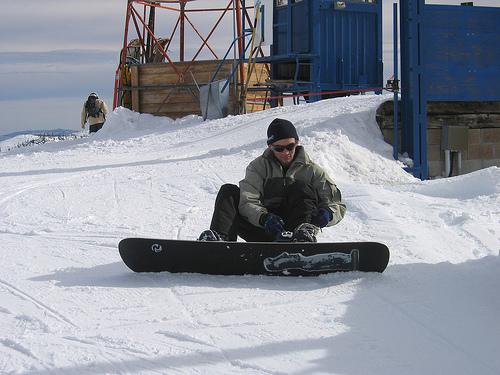Question: what is the man doing?
Choices:
A. Sitting.
B. Eating.
C. Dancing.
D. Walking.
Answer with the letter. Answer: A Question: who is sitting?
Choices:
A. A man.
B. A woman.
C. A dog.
D. A cat.
Answer with the letter. Answer: A Question: why is the man sitting?
Choices:
A. Eating his dinner.
B. Tying his shoe.
C. Tired of standing.
D. Fixing his snowboard.
Answer with the letter. Answer: D Question: when was the photo taken?
Choices:
A. Night time.
B. Winter.
C. Summer.
D. Day time.
Answer with the letter. Answer: D Question: what color is the snowboard?
Choices:
A. White.
B. Pink.
C. Green.
D. Black.
Answer with the letter. Answer: D Question: what time of day is it?
Choices:
A. Evening.
B. Morning.
C. Afternoon.
D. Mid day.
Answer with the letter. Answer: C Question: what is the man sitting on?
Choices:
A. Chair.
B. Snow.
C. Bridge.
D. Grass.
Answer with the letter. Answer: B 